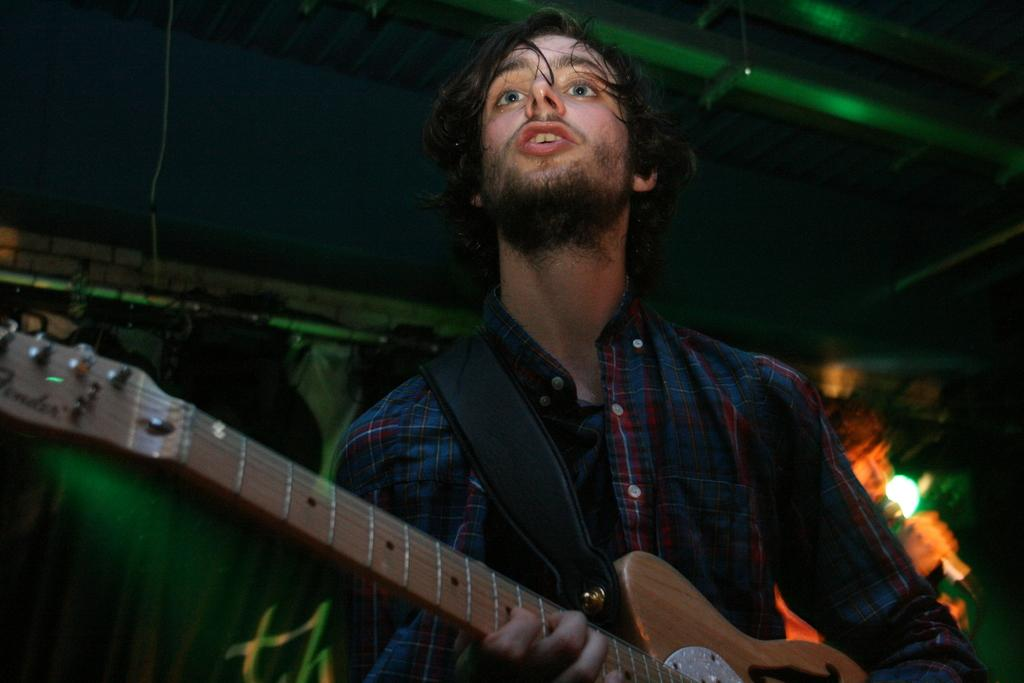What is the main subject of the image? There is a man in the image. What is the man doing in the image? The man is playing a guitar. What type of jewel is the man wearing on his neck in the image? There is no mention of a jewel or anything being worn around the man's neck in the image. 